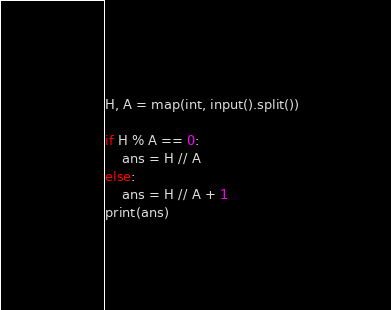<code> <loc_0><loc_0><loc_500><loc_500><_Python_>H, A = map(int, input().split())

if H % A == 0:
    ans = H // A
else:
    ans = H // A + 1
print(ans)
</code> 